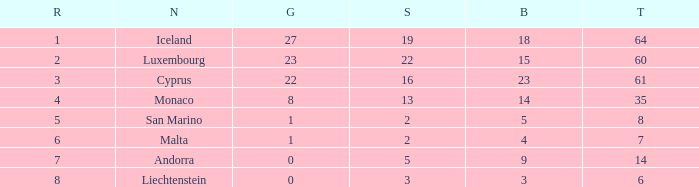How many golds for the nation with 14 total? 0.0. 